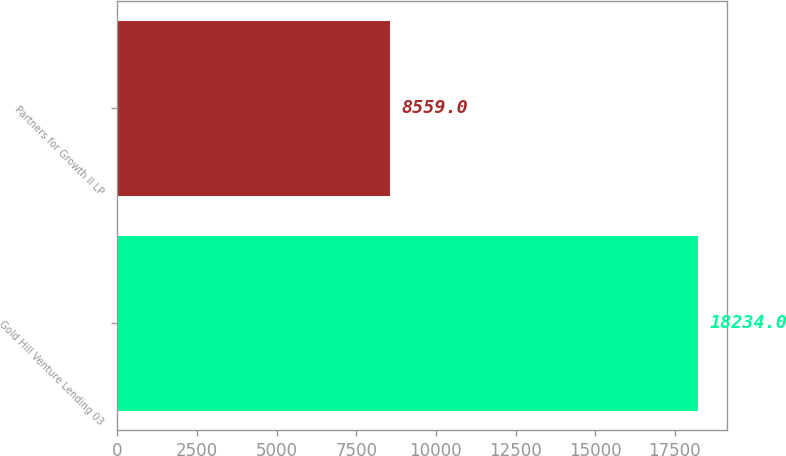Convert chart. <chart><loc_0><loc_0><loc_500><loc_500><bar_chart><fcel>Gold Hill Venture Lending 03<fcel>Partners for Growth II LP<nl><fcel>18234<fcel>8559<nl></chart> 